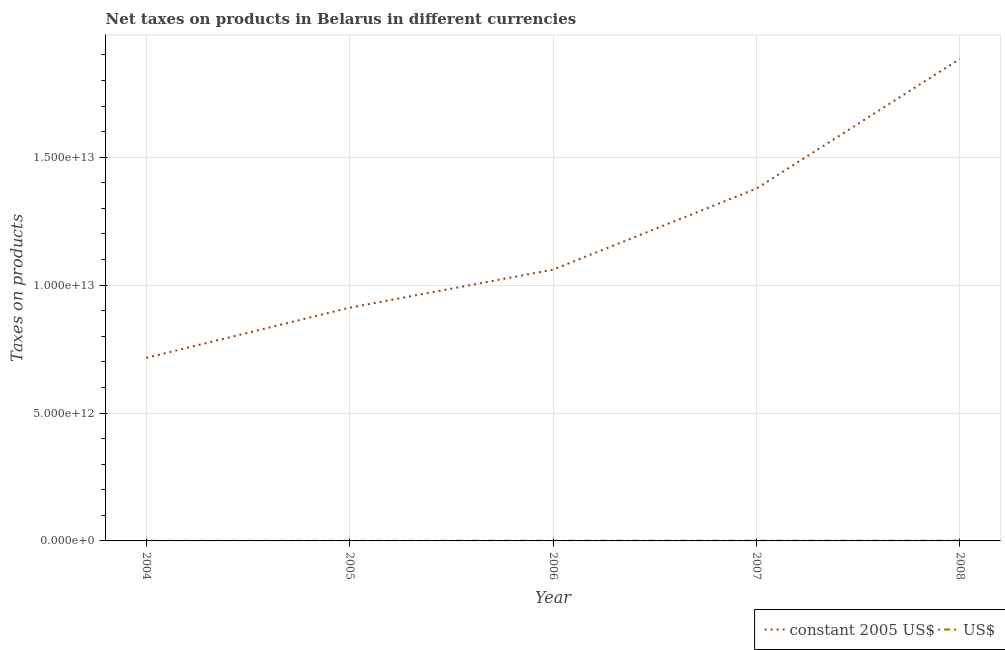How many different coloured lines are there?
Keep it short and to the point. 2. Does the line corresponding to net taxes in constant 2005 us$ intersect with the line corresponding to net taxes in us$?
Give a very brief answer. No. Is the number of lines equal to the number of legend labels?
Ensure brevity in your answer.  Yes. What is the net taxes in us$ in 2005?
Your response must be concise. 4.23e+09. Across all years, what is the maximum net taxes in us$?
Provide a short and direct response. 8.82e+09. Across all years, what is the minimum net taxes in us$?
Provide a succinct answer. 3.31e+09. In which year was the net taxes in constant 2005 us$ maximum?
Keep it short and to the point. 2008. What is the total net taxes in us$ in the graph?
Make the answer very short. 2.77e+1. What is the difference between the net taxes in constant 2005 us$ in 2004 and that in 2005?
Your answer should be compact. -1.96e+12. What is the difference between the net taxes in us$ in 2005 and the net taxes in constant 2005 us$ in 2006?
Ensure brevity in your answer.  -1.06e+13. What is the average net taxes in us$ per year?
Provide a succinct answer. 5.55e+09. In the year 2008, what is the difference between the net taxes in us$ and net taxes in constant 2005 us$?
Your answer should be very brief. -1.88e+13. What is the ratio of the net taxes in constant 2005 us$ in 2004 to that in 2005?
Provide a short and direct response. 0.78. Is the net taxes in us$ in 2004 less than that in 2007?
Offer a very short reply. Yes. Is the difference between the net taxes in constant 2005 us$ in 2005 and 2007 greater than the difference between the net taxes in us$ in 2005 and 2007?
Provide a short and direct response. No. What is the difference between the highest and the second highest net taxes in constant 2005 us$?
Give a very brief answer. 5.07e+12. What is the difference between the highest and the lowest net taxes in constant 2005 us$?
Your response must be concise. 1.17e+13. Is the sum of the net taxes in us$ in 2007 and 2008 greater than the maximum net taxes in constant 2005 us$ across all years?
Your response must be concise. No. Does the net taxes in constant 2005 us$ monotonically increase over the years?
Ensure brevity in your answer.  Yes. What is the difference between two consecutive major ticks on the Y-axis?
Provide a short and direct response. 5.00e+12. Are the values on the major ticks of Y-axis written in scientific E-notation?
Provide a succinct answer. Yes. Does the graph contain any zero values?
Give a very brief answer. No. What is the title of the graph?
Provide a succinct answer. Net taxes on products in Belarus in different currencies. What is the label or title of the Y-axis?
Your answer should be very brief. Taxes on products. What is the Taxes on products of constant 2005 US$ in 2004?
Your response must be concise. 7.16e+12. What is the Taxes on products of US$ in 2004?
Offer a terse response. 3.31e+09. What is the Taxes on products of constant 2005 US$ in 2005?
Your answer should be very brief. 9.12e+12. What is the Taxes on products of US$ in 2005?
Provide a succinct answer. 4.23e+09. What is the Taxes on products of constant 2005 US$ in 2006?
Provide a short and direct response. 1.06e+13. What is the Taxes on products in US$ in 2006?
Offer a terse response. 4.95e+09. What is the Taxes on products in constant 2005 US$ in 2007?
Keep it short and to the point. 1.38e+13. What is the Taxes on products in US$ in 2007?
Your answer should be very brief. 6.42e+09. What is the Taxes on products in constant 2005 US$ in 2008?
Keep it short and to the point. 1.88e+13. What is the Taxes on products of US$ in 2008?
Provide a succinct answer. 8.82e+09. Across all years, what is the maximum Taxes on products in constant 2005 US$?
Your answer should be compact. 1.88e+13. Across all years, what is the maximum Taxes on products in US$?
Provide a succinct answer. 8.82e+09. Across all years, what is the minimum Taxes on products of constant 2005 US$?
Offer a very short reply. 7.16e+12. Across all years, what is the minimum Taxes on products of US$?
Ensure brevity in your answer.  3.31e+09. What is the total Taxes on products of constant 2005 US$ in the graph?
Keep it short and to the point. 5.95e+13. What is the total Taxes on products of US$ in the graph?
Give a very brief answer. 2.77e+1. What is the difference between the Taxes on products in constant 2005 US$ in 2004 and that in 2005?
Make the answer very short. -1.96e+12. What is the difference between the Taxes on products in US$ in 2004 and that in 2005?
Ensure brevity in your answer.  -9.21e+08. What is the difference between the Taxes on products of constant 2005 US$ in 2004 and that in 2006?
Give a very brief answer. -3.45e+12. What is the difference between the Taxes on products of US$ in 2004 and that in 2006?
Provide a short and direct response. -1.63e+09. What is the difference between the Taxes on products in constant 2005 US$ in 2004 and that in 2007?
Provide a succinct answer. -6.62e+12. What is the difference between the Taxes on products of US$ in 2004 and that in 2007?
Provide a succinct answer. -3.11e+09. What is the difference between the Taxes on products in constant 2005 US$ in 2004 and that in 2008?
Offer a very short reply. -1.17e+13. What is the difference between the Taxes on products of US$ in 2004 and that in 2008?
Offer a terse response. -5.51e+09. What is the difference between the Taxes on products in constant 2005 US$ in 2005 and that in 2006?
Provide a succinct answer. -1.49e+12. What is the difference between the Taxes on products of US$ in 2005 and that in 2006?
Your answer should be compact. -7.12e+08. What is the difference between the Taxes on products in constant 2005 US$ in 2005 and that in 2007?
Your answer should be very brief. -4.66e+12. What is the difference between the Taxes on products of US$ in 2005 and that in 2007?
Ensure brevity in your answer.  -2.19e+09. What is the difference between the Taxes on products of constant 2005 US$ in 2005 and that in 2008?
Your answer should be very brief. -9.72e+12. What is the difference between the Taxes on products of US$ in 2005 and that in 2008?
Provide a succinct answer. -4.59e+09. What is the difference between the Taxes on products in constant 2005 US$ in 2006 and that in 2007?
Offer a terse response. -3.17e+12. What is the difference between the Taxes on products of US$ in 2006 and that in 2007?
Keep it short and to the point. -1.47e+09. What is the difference between the Taxes on products in constant 2005 US$ in 2006 and that in 2008?
Your answer should be compact. -8.24e+12. What is the difference between the Taxes on products in US$ in 2006 and that in 2008?
Make the answer very short. -3.87e+09. What is the difference between the Taxes on products of constant 2005 US$ in 2007 and that in 2008?
Offer a terse response. -5.07e+12. What is the difference between the Taxes on products of US$ in 2007 and that in 2008?
Provide a succinct answer. -2.40e+09. What is the difference between the Taxes on products in constant 2005 US$ in 2004 and the Taxes on products in US$ in 2005?
Your answer should be compact. 7.15e+12. What is the difference between the Taxes on products in constant 2005 US$ in 2004 and the Taxes on products in US$ in 2006?
Make the answer very short. 7.15e+12. What is the difference between the Taxes on products in constant 2005 US$ in 2004 and the Taxes on products in US$ in 2007?
Offer a very short reply. 7.15e+12. What is the difference between the Taxes on products of constant 2005 US$ in 2004 and the Taxes on products of US$ in 2008?
Keep it short and to the point. 7.15e+12. What is the difference between the Taxes on products of constant 2005 US$ in 2005 and the Taxes on products of US$ in 2006?
Provide a succinct answer. 9.11e+12. What is the difference between the Taxes on products of constant 2005 US$ in 2005 and the Taxes on products of US$ in 2007?
Provide a short and direct response. 9.11e+12. What is the difference between the Taxes on products of constant 2005 US$ in 2005 and the Taxes on products of US$ in 2008?
Offer a terse response. 9.11e+12. What is the difference between the Taxes on products in constant 2005 US$ in 2006 and the Taxes on products in US$ in 2007?
Your answer should be compact. 1.06e+13. What is the difference between the Taxes on products of constant 2005 US$ in 2006 and the Taxes on products of US$ in 2008?
Give a very brief answer. 1.06e+13. What is the difference between the Taxes on products in constant 2005 US$ in 2007 and the Taxes on products in US$ in 2008?
Offer a terse response. 1.38e+13. What is the average Taxes on products in constant 2005 US$ per year?
Provide a succinct answer. 1.19e+13. What is the average Taxes on products in US$ per year?
Give a very brief answer. 5.55e+09. In the year 2004, what is the difference between the Taxes on products of constant 2005 US$ and Taxes on products of US$?
Ensure brevity in your answer.  7.15e+12. In the year 2005, what is the difference between the Taxes on products of constant 2005 US$ and Taxes on products of US$?
Give a very brief answer. 9.11e+12. In the year 2006, what is the difference between the Taxes on products of constant 2005 US$ and Taxes on products of US$?
Provide a succinct answer. 1.06e+13. In the year 2007, what is the difference between the Taxes on products of constant 2005 US$ and Taxes on products of US$?
Keep it short and to the point. 1.38e+13. In the year 2008, what is the difference between the Taxes on products of constant 2005 US$ and Taxes on products of US$?
Provide a short and direct response. 1.88e+13. What is the ratio of the Taxes on products of constant 2005 US$ in 2004 to that in 2005?
Make the answer very short. 0.78. What is the ratio of the Taxes on products in US$ in 2004 to that in 2005?
Offer a terse response. 0.78. What is the ratio of the Taxes on products of constant 2005 US$ in 2004 to that in 2006?
Your response must be concise. 0.67. What is the ratio of the Taxes on products in US$ in 2004 to that in 2006?
Your response must be concise. 0.67. What is the ratio of the Taxes on products of constant 2005 US$ in 2004 to that in 2007?
Keep it short and to the point. 0.52. What is the ratio of the Taxes on products of US$ in 2004 to that in 2007?
Keep it short and to the point. 0.52. What is the ratio of the Taxes on products of constant 2005 US$ in 2004 to that in 2008?
Offer a terse response. 0.38. What is the ratio of the Taxes on products of US$ in 2004 to that in 2008?
Ensure brevity in your answer.  0.38. What is the ratio of the Taxes on products in constant 2005 US$ in 2005 to that in 2006?
Offer a very short reply. 0.86. What is the ratio of the Taxes on products in US$ in 2005 to that in 2006?
Make the answer very short. 0.86. What is the ratio of the Taxes on products in constant 2005 US$ in 2005 to that in 2007?
Give a very brief answer. 0.66. What is the ratio of the Taxes on products of US$ in 2005 to that in 2007?
Provide a succinct answer. 0.66. What is the ratio of the Taxes on products of constant 2005 US$ in 2005 to that in 2008?
Your answer should be compact. 0.48. What is the ratio of the Taxes on products in US$ in 2005 to that in 2008?
Keep it short and to the point. 0.48. What is the ratio of the Taxes on products of constant 2005 US$ in 2006 to that in 2007?
Your answer should be compact. 0.77. What is the ratio of the Taxes on products of US$ in 2006 to that in 2007?
Make the answer very short. 0.77. What is the ratio of the Taxes on products of constant 2005 US$ in 2006 to that in 2008?
Offer a terse response. 0.56. What is the ratio of the Taxes on products in US$ in 2006 to that in 2008?
Provide a short and direct response. 0.56. What is the ratio of the Taxes on products in constant 2005 US$ in 2007 to that in 2008?
Offer a terse response. 0.73. What is the ratio of the Taxes on products in US$ in 2007 to that in 2008?
Offer a very short reply. 0.73. What is the difference between the highest and the second highest Taxes on products of constant 2005 US$?
Offer a very short reply. 5.07e+12. What is the difference between the highest and the second highest Taxes on products of US$?
Make the answer very short. 2.40e+09. What is the difference between the highest and the lowest Taxes on products of constant 2005 US$?
Offer a terse response. 1.17e+13. What is the difference between the highest and the lowest Taxes on products of US$?
Your response must be concise. 5.51e+09. 